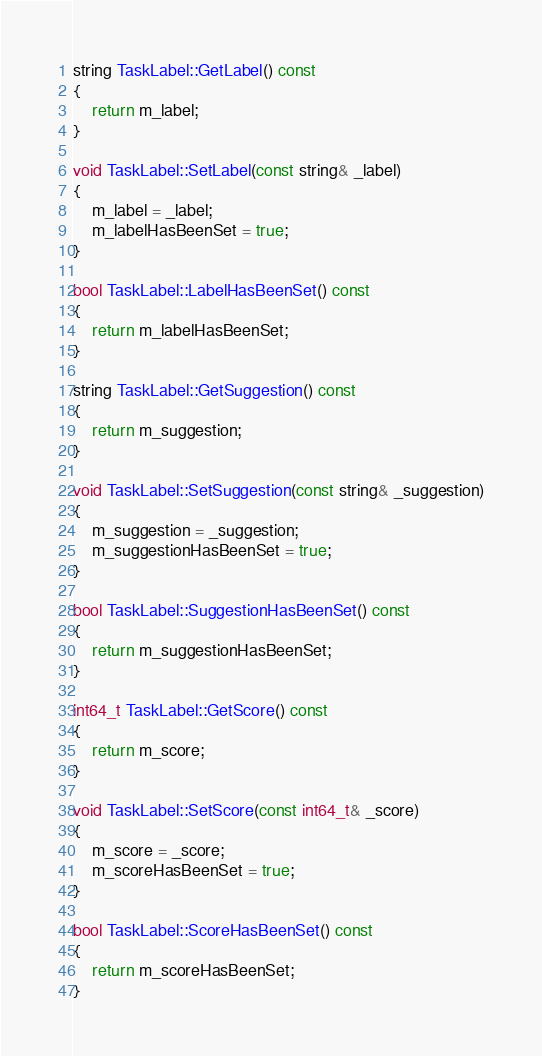<code> <loc_0><loc_0><loc_500><loc_500><_C++_>string TaskLabel::GetLabel() const
{
    return m_label;
}

void TaskLabel::SetLabel(const string& _label)
{
    m_label = _label;
    m_labelHasBeenSet = true;
}

bool TaskLabel::LabelHasBeenSet() const
{
    return m_labelHasBeenSet;
}

string TaskLabel::GetSuggestion() const
{
    return m_suggestion;
}

void TaskLabel::SetSuggestion(const string& _suggestion)
{
    m_suggestion = _suggestion;
    m_suggestionHasBeenSet = true;
}

bool TaskLabel::SuggestionHasBeenSet() const
{
    return m_suggestionHasBeenSet;
}

int64_t TaskLabel::GetScore() const
{
    return m_score;
}

void TaskLabel::SetScore(const int64_t& _score)
{
    m_score = _score;
    m_scoreHasBeenSet = true;
}

bool TaskLabel::ScoreHasBeenSet() const
{
    return m_scoreHasBeenSet;
}

</code> 